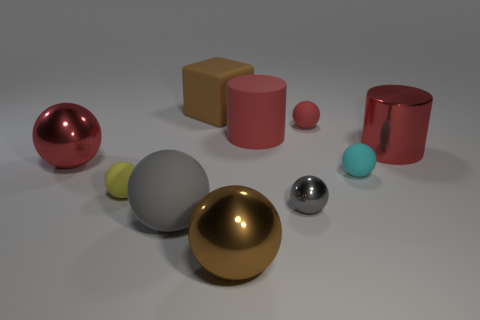Subtract all matte spheres. How many spheres are left? 3 Subtract all cyan spheres. How many spheres are left? 6 Subtract all cylinders. How many objects are left? 8 Subtract 1 cylinders. How many cylinders are left? 1 Add 8 purple rubber things. How many purple rubber things exist? 8 Subtract 0 cyan blocks. How many objects are left? 10 Subtract all purple balls. Subtract all yellow cylinders. How many balls are left? 7 Subtract all red balls. How many gray cubes are left? 0 Subtract all small red rubber spheres. Subtract all small rubber cylinders. How many objects are left? 9 Add 5 tiny shiny balls. How many tiny shiny balls are left? 6 